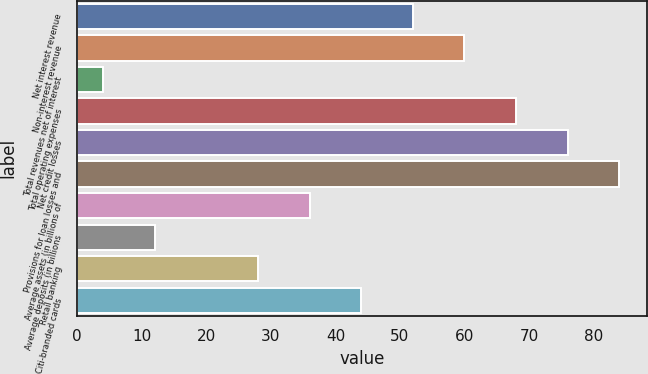<chart> <loc_0><loc_0><loc_500><loc_500><bar_chart><fcel>Net interest revenue<fcel>Non-interest revenue<fcel>Total revenues net of interest<fcel>Total operating expenses<fcel>Net credit losses<fcel>Provisions for loan losses and<fcel>Average assets (in billions of<fcel>Average deposits (in billions<fcel>Retail banking<fcel>Citi-branded cards<nl><fcel>52<fcel>60<fcel>4<fcel>68<fcel>76<fcel>84<fcel>36<fcel>12<fcel>28<fcel>44<nl></chart> 